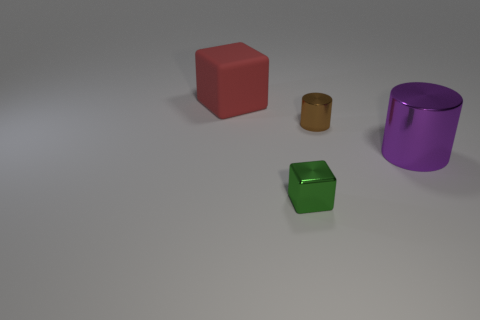There is a object that is to the left of the tiny metal cylinder and on the right side of the red thing; what color is it?
Your answer should be very brief. Green. There is a small shiny thing behind the shiny block; how many metallic objects are behind it?
Give a very brief answer. 0. Is the number of large purple things that are in front of the big metallic thing greater than the number of green shiny blocks right of the brown cylinder?
Offer a very short reply. No. What is the brown cylinder made of?
Make the answer very short. Metal. Are there any brown metallic things of the same size as the brown metallic cylinder?
Keep it short and to the point. No. There is a block that is the same size as the brown cylinder; what is it made of?
Provide a succinct answer. Metal. What number of tiny brown metallic cylinders are there?
Your answer should be very brief. 1. There is a metal cylinder to the left of the large purple cylinder; how big is it?
Your answer should be compact. Small. Are there an equal number of cylinders that are behind the red rubber block and big things?
Your answer should be compact. No. Are there any small brown things that have the same shape as the tiny green shiny thing?
Provide a short and direct response. No. 